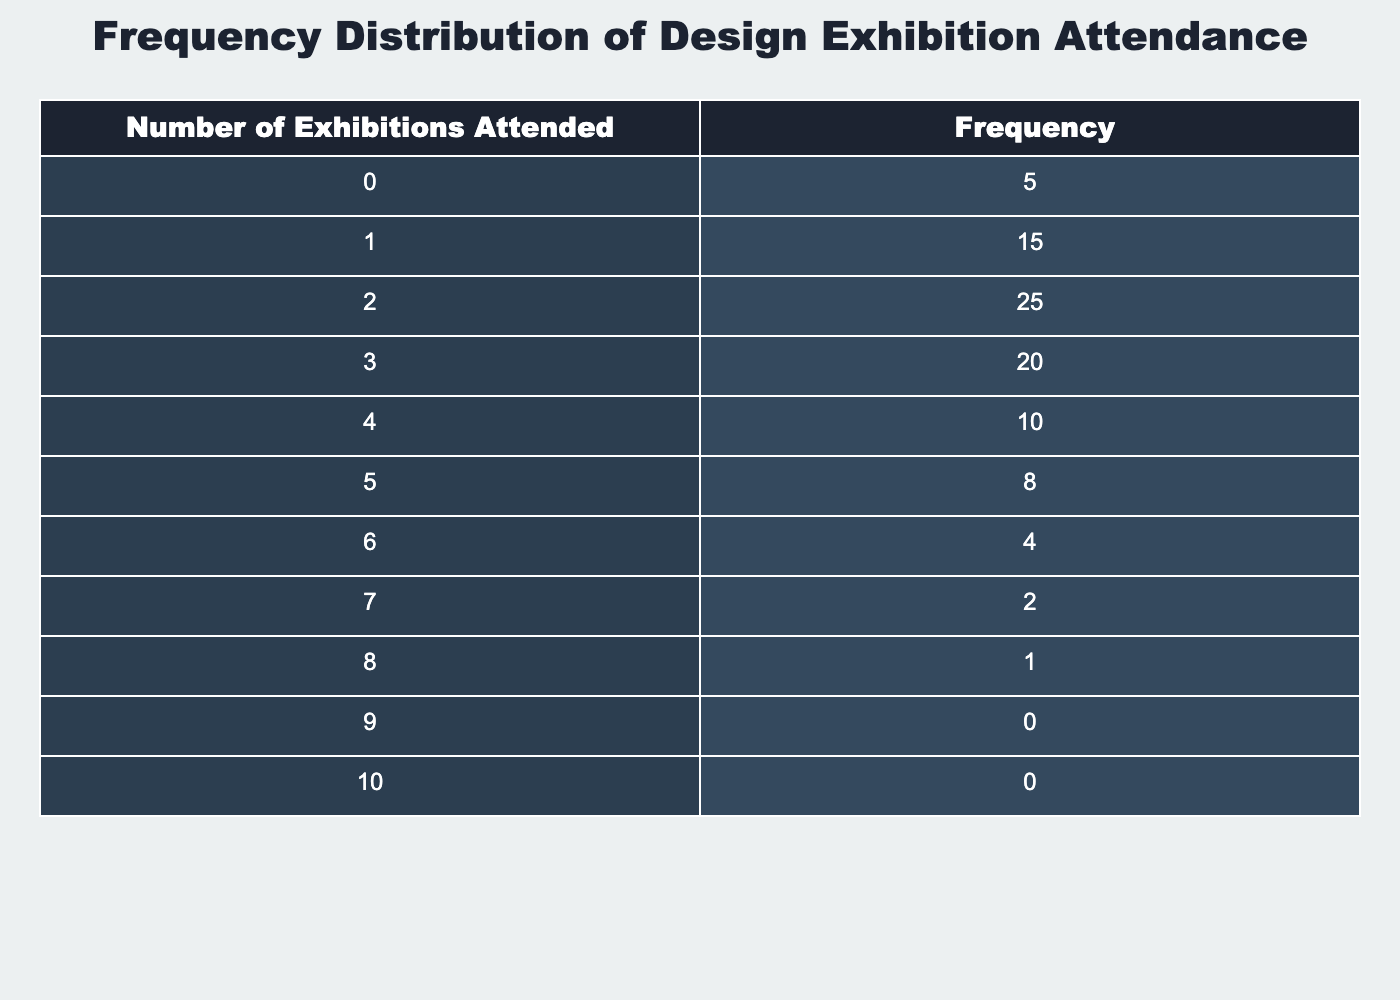What is the frequency of students who attended 3 exhibitions? According to the table, the frequency of students who attended 3 exhibitions is listed under the corresponding row, which shows a value of 20.
Answer: 20 What is the total number of students who attended at least 2 exhibitions? To find the total number of students who attended at least 2 exhibitions, sum the frequencies for 2, 3, 4, 5, 6, 7, 8, 9, and 10 exhibitions: 25 + 20 + 10 + 8 + 4 + 2 + 1 + 0 + 0 = 70.
Answer: 70 Is it true that more students attended 1 exhibition than 4 exhibitions? By comparing the frequencies, 15 students attended 1 exhibition and 10 students attended 4 exhibitions. Since 15 is greater than 10, the statement is true.
Answer: Yes What is the average number of exhibitions attended by all students? First, calculate the total number of exhibitions attended: (0*5 + 1*15 + 2*25 + 3*20 + 4*10 + 5*8 + 6*4 + 7*2 + 8*1 + 9*0 + 10*0) = (0 + 15 + 50 + 60 + 40 + 40 + 24 + 14 + 8 + 0 + 0) = 247. Then, calculate the total number of students by summing all frequencies: 5 + 15 + 25 + 20 + 10 + 8 + 4 + 2 + 1 + 0 + 0 = 100. Finally, the average is 247 / 100 = 2.47.
Answer: 2.47 How many students attended more than 6 exhibitions? To find the number of students who attended more than 6 exhibitions, sum the frequencies for 7, 8, 9, and 10 exhibitions: 2 + 1 + 0 + 0 = 3.
Answer: 3 